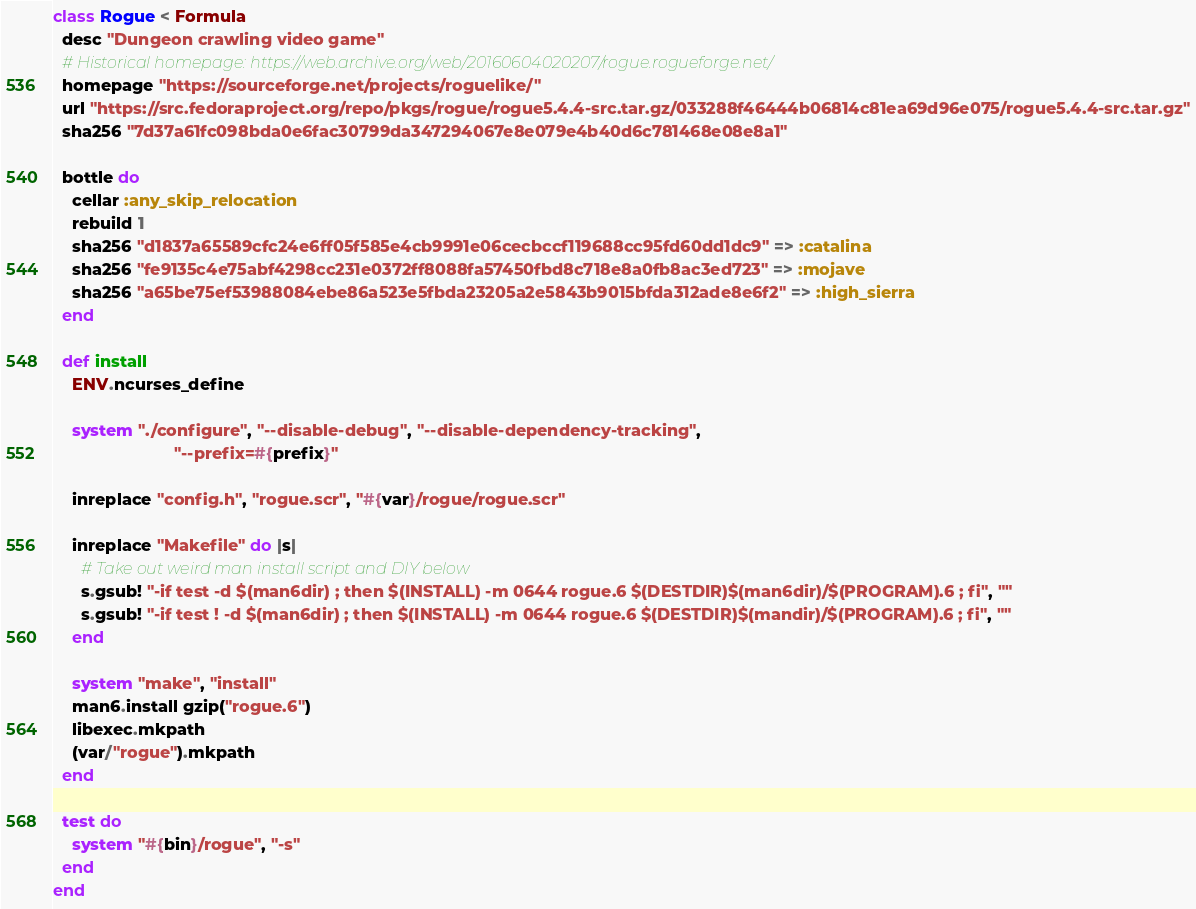Convert code to text. <code><loc_0><loc_0><loc_500><loc_500><_Ruby_>class Rogue < Formula
  desc "Dungeon crawling video game"
  # Historical homepage: https://web.archive.org/web/20160604020207/rogue.rogueforge.net/
  homepage "https://sourceforge.net/projects/roguelike/"
  url "https://src.fedoraproject.org/repo/pkgs/rogue/rogue5.4.4-src.tar.gz/033288f46444b06814c81ea69d96e075/rogue5.4.4-src.tar.gz"
  sha256 "7d37a61fc098bda0e6fac30799da347294067e8e079e4b40d6c781468e08e8a1"

  bottle do
    cellar :any_skip_relocation
    rebuild 1
    sha256 "d1837a65589cfc24e6ff05f585e4cb9991e06cecbccf119688cc95fd60dd1dc9" => :catalina
    sha256 "fe9135c4e75abf4298cc231e0372ff8088fa57450fbd8c718e8a0fb8ac3ed723" => :mojave
    sha256 "a65be75ef53988084ebe86a523e5fbda23205a2e5843b9015bfda312ade8e6f2" => :high_sierra
  end

  def install
    ENV.ncurses_define

    system "./configure", "--disable-debug", "--disable-dependency-tracking",
                          "--prefix=#{prefix}"

    inreplace "config.h", "rogue.scr", "#{var}/rogue/rogue.scr"

    inreplace "Makefile" do |s|
      # Take out weird man install script and DIY below
      s.gsub! "-if test -d $(man6dir) ; then $(INSTALL) -m 0644 rogue.6 $(DESTDIR)$(man6dir)/$(PROGRAM).6 ; fi", ""
      s.gsub! "-if test ! -d $(man6dir) ; then $(INSTALL) -m 0644 rogue.6 $(DESTDIR)$(mandir)/$(PROGRAM).6 ; fi", ""
    end

    system "make", "install"
    man6.install gzip("rogue.6")
    libexec.mkpath
    (var/"rogue").mkpath
  end

  test do
    system "#{bin}/rogue", "-s"
  end
end
</code> 